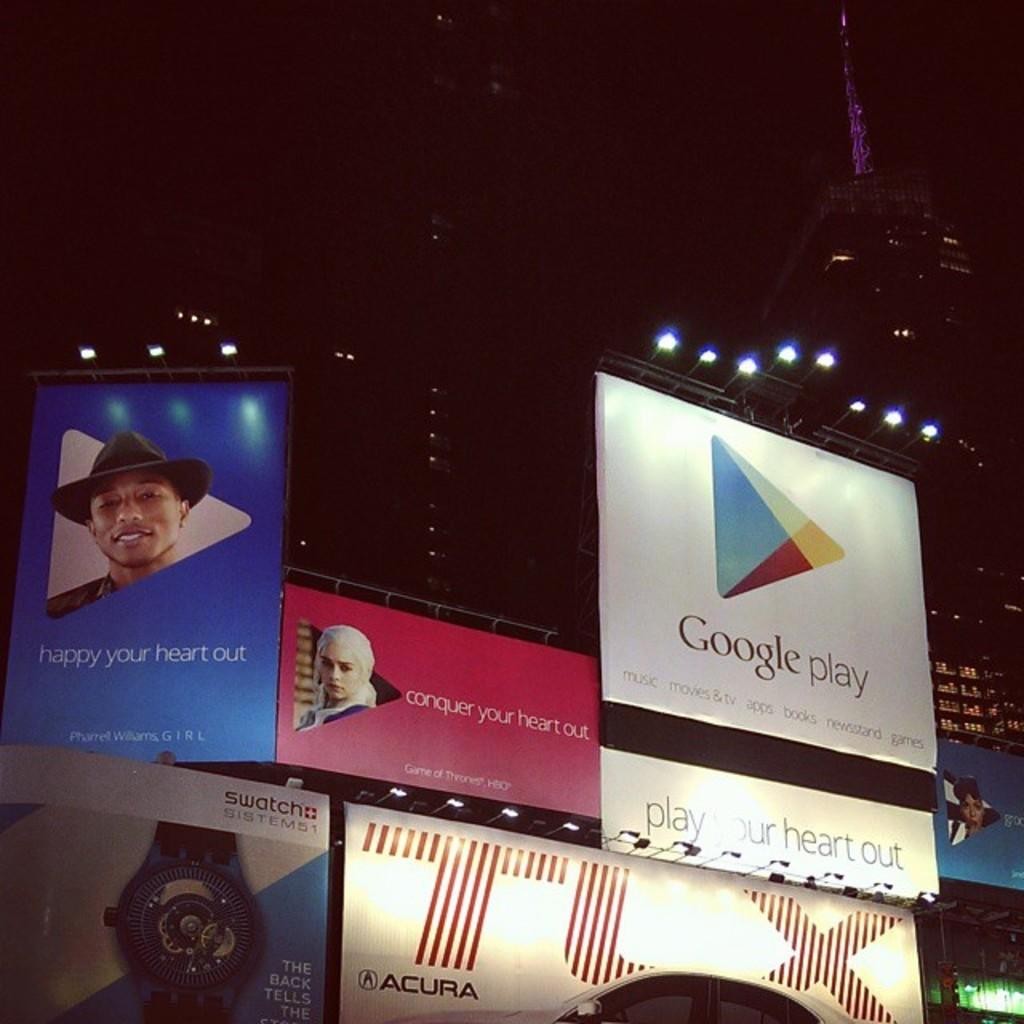<image>
Provide a brief description of the given image. Several billboards including one for Google play are underneath stadium lights, at night. 